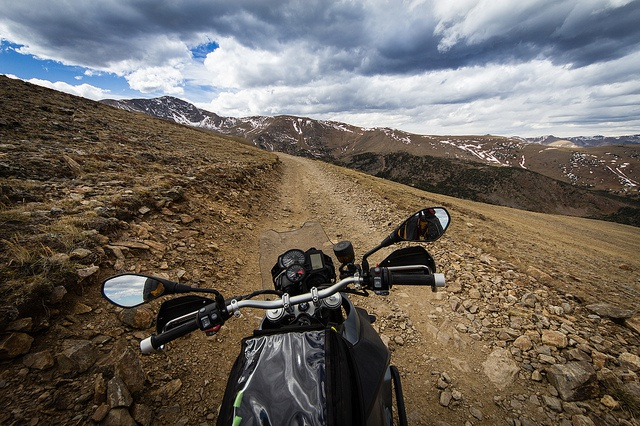Describe the objects in this image and their specific colors. I can see a motorcycle in darkgray, black, and gray tones in this image. 